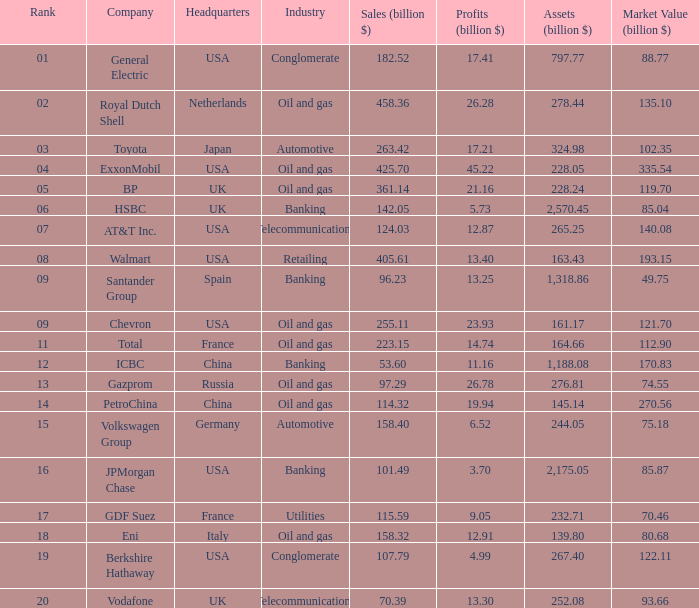Could you help me parse every detail presented in this table? {'header': ['Rank', 'Company', 'Headquarters', 'Industry', 'Sales (billion $)', 'Profits (billion $)', 'Assets (billion $)', 'Market Value (billion $)'], 'rows': [['01', 'General Electric', 'USA', 'Conglomerate', '182.52', '17.41', '797.77', '88.77'], ['02', 'Royal Dutch Shell', 'Netherlands', 'Oil and gas', '458.36', '26.28', '278.44', '135.10'], ['03', 'Toyota', 'Japan', 'Automotive', '263.42', '17.21', '324.98', '102.35'], ['04', 'ExxonMobil', 'USA', 'Oil and gas', '425.70', '45.22', '228.05', '335.54'], ['05', 'BP', 'UK', 'Oil and gas', '361.14', '21.16', '228.24', '119.70'], ['06', 'HSBC', 'UK', 'Banking', '142.05', '5.73', '2,570.45', '85.04'], ['07', 'AT&T Inc.', 'USA', 'Telecommunications', '124.03', '12.87', '265.25', '140.08'], ['08', 'Walmart', 'USA', 'Retailing', '405.61', '13.40', '163.43', '193.15'], ['09', 'Santander Group', 'Spain', 'Banking', '96.23', '13.25', '1,318.86', '49.75'], ['09', 'Chevron', 'USA', 'Oil and gas', '255.11', '23.93', '161.17', '121.70'], ['11', 'Total', 'France', 'Oil and gas', '223.15', '14.74', '164.66', '112.90'], ['12', 'ICBC', 'China', 'Banking', '53.60', '11.16', '1,188.08', '170.83'], ['13', 'Gazprom', 'Russia', 'Oil and gas', '97.29', '26.78', '276.81', '74.55'], ['14', 'PetroChina', 'China', 'Oil and gas', '114.32', '19.94', '145.14', '270.56'], ['15', 'Volkswagen Group', 'Germany', 'Automotive', '158.40', '6.52', '244.05', '75.18'], ['16', 'JPMorgan Chase', 'USA', 'Banking', '101.49', '3.70', '2,175.05', '85.87'], ['17', 'GDF Suez', 'France', 'Utilities', '115.59', '9.05', '232.71', '70.46'], ['18', 'Eni', 'Italy', 'Oil and gas', '158.32', '12.91', '139.80', '80.68'], ['19', 'Berkshire Hathaway', 'USA', 'Conglomerate', '107.79', '4.99', '267.40', '122.11'], ['20', 'Vodafone', 'UK', 'Telecommunications', '70.39', '13.30', '252.08', '93.66']]} Name the Sales (billion $) which have a Company of exxonmobil? 425.7. 